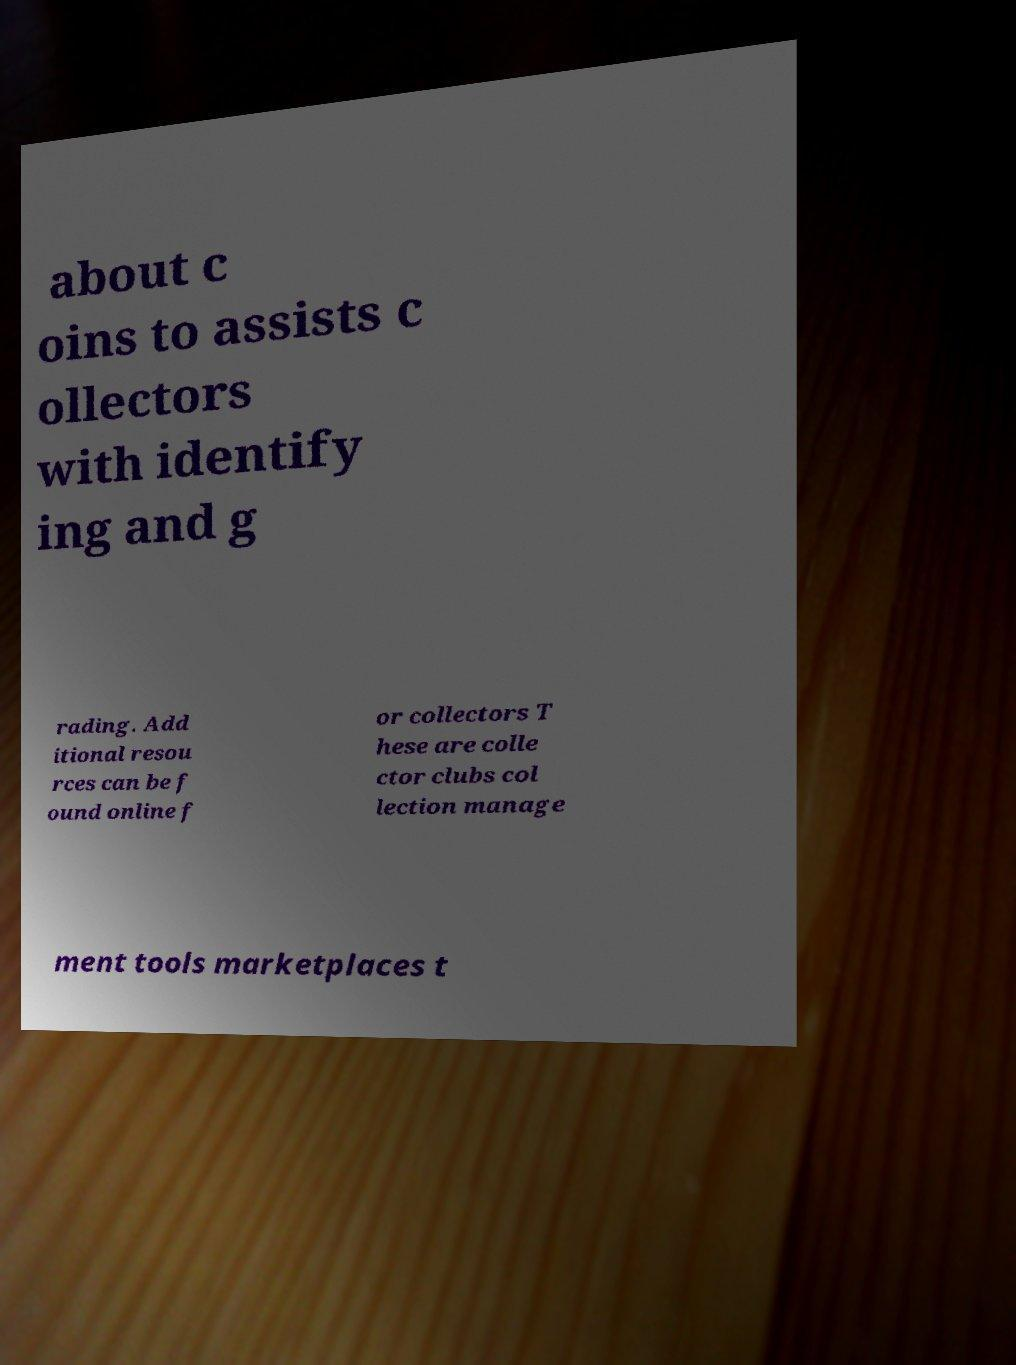There's text embedded in this image that I need extracted. Can you transcribe it verbatim? about c oins to assists c ollectors with identify ing and g rading. Add itional resou rces can be f ound online f or collectors T hese are colle ctor clubs col lection manage ment tools marketplaces t 